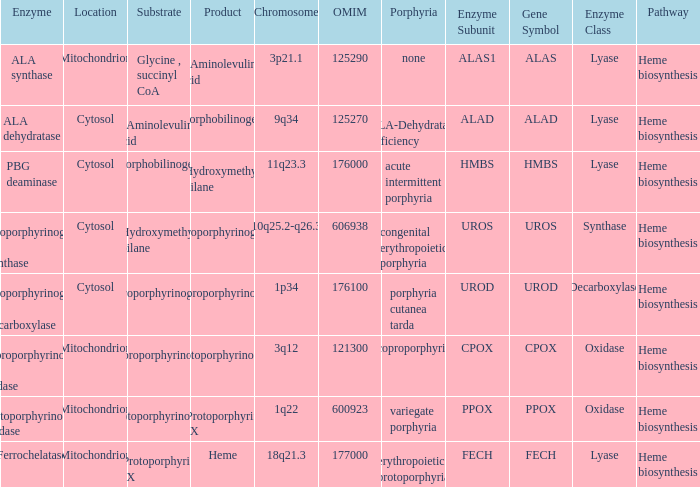What is the location of the enzyme Uroporphyrinogen iii Synthase? Cytosol. Write the full table. {'header': ['Enzyme', 'Location', 'Substrate', 'Product', 'Chromosome', 'OMIM', 'Porphyria', 'Enzyme Subunit', 'Gene Symbol', 'Enzyme Class', 'Pathway'], 'rows': [['ALA synthase', 'Mitochondrion', 'Glycine , succinyl CoA', 'δ-Aminolevulinic acid', '3p21.1', '125290', 'none', 'ALAS1', 'ALAS', 'Lyase', 'Heme biosynthesis'], ['ALA dehydratase', 'Cytosol', 'δ-Aminolevulinic acid', 'Porphobilinogen', '9q34', '125270', 'ALA-Dehydratase deficiency', 'ALAD', 'ALAD', 'Lyase', 'Heme biosynthesis'], ['PBG deaminase', 'Cytosol', 'Porphobilinogen', 'Hydroxymethyl bilane', '11q23.3', '176000', 'acute intermittent porphyria', 'HMBS', 'HMBS', 'Lyase', 'Heme biosynthesis'], ['Uroporphyrinogen III synthase', 'Cytosol', 'Hydroxymethyl bilane', 'Uroporphyrinogen III', '10q25.2-q26.3', '606938', 'congenital erythropoietic porphyria', 'UROS', 'UROS', 'Synthase', 'Heme biosynthesis'], ['Uroporphyrinogen III decarboxylase', 'Cytosol', 'Uroporphyrinogen III', 'Coproporphyrinogen III', '1p34', '176100', 'porphyria cutanea tarda', 'UROD', 'UROD', 'Decarboxylase', 'Heme biosynthesis'], ['Coproporphyrinogen III oxidase', 'Mitochondrion', 'Coproporphyrinogen III', 'Protoporphyrinogen IX', '3q12', '121300', 'coproporphyria', 'CPOX', 'CPOX', 'Oxidase', 'Heme biosynthesis'], ['Protoporphyrinogen oxidase', 'Mitochondrion', 'Protoporphyrinogen IX', 'Protoporphyrin IX', '1q22', '600923', 'variegate porphyria', 'PPOX', 'PPOX', 'Oxidase', 'Heme biosynthesis'], ['Ferrochelatase', 'Mitochondrion', 'Protoporphyrin IX', 'Heme', '18q21.3', '177000', 'erythropoietic protoporphyria', 'FECH', 'FECH', 'Lyase', 'Heme biosynthesis']]} 